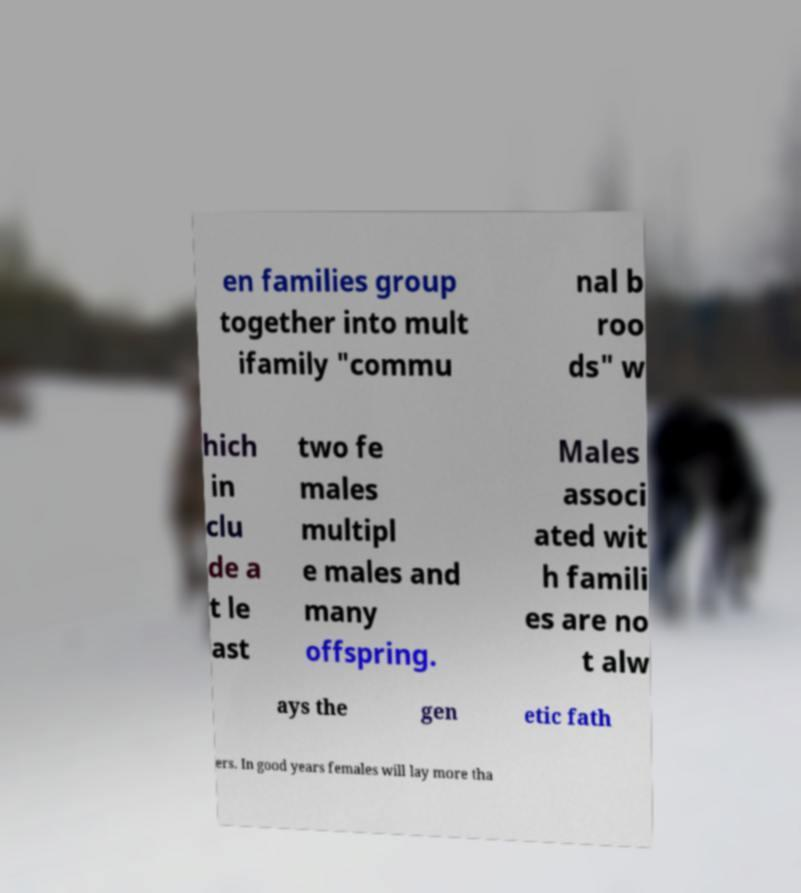For documentation purposes, I need the text within this image transcribed. Could you provide that? en families group together into mult ifamily "commu nal b roo ds" w hich in clu de a t le ast two fe males multipl e males and many offspring. Males associ ated wit h famili es are no t alw ays the gen etic fath ers. In good years females will lay more tha 